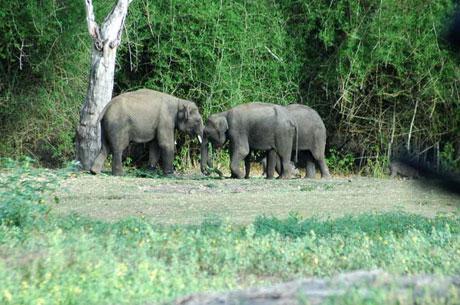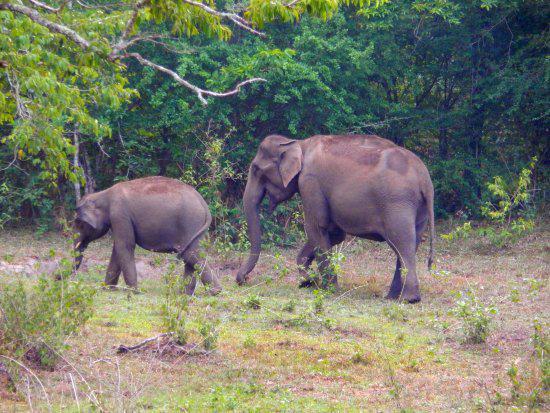The first image is the image on the left, the second image is the image on the right. Evaluate the accuracy of this statement regarding the images: "Some of the animals are near the water.". Is it true? Answer yes or no. No. 